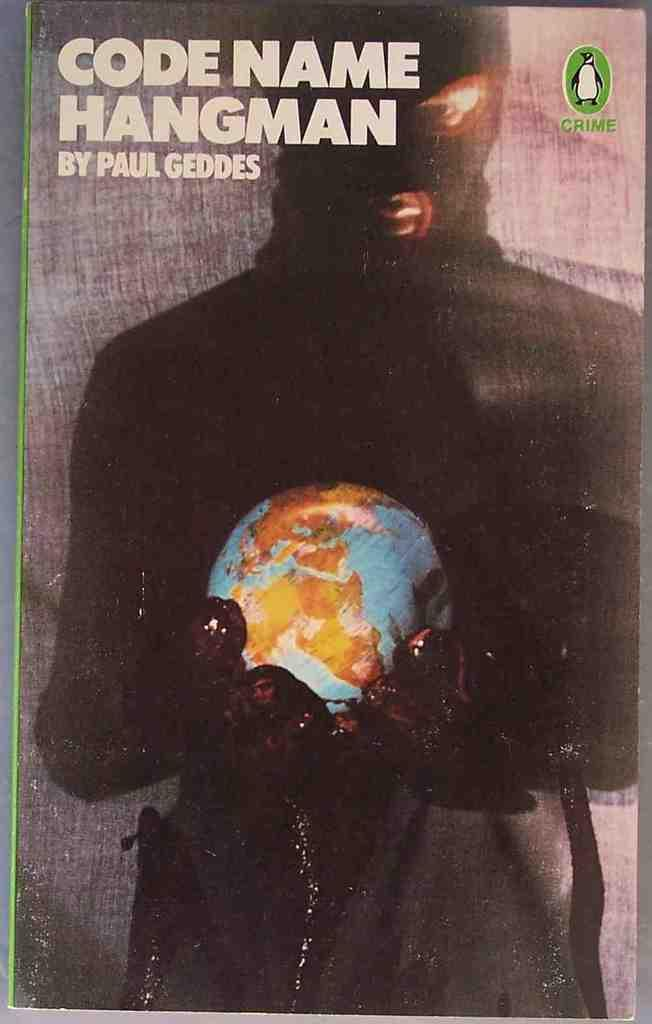<image>
Share a concise interpretation of the image provided. Paul Geddes wrote a book called Code Name Hangman 